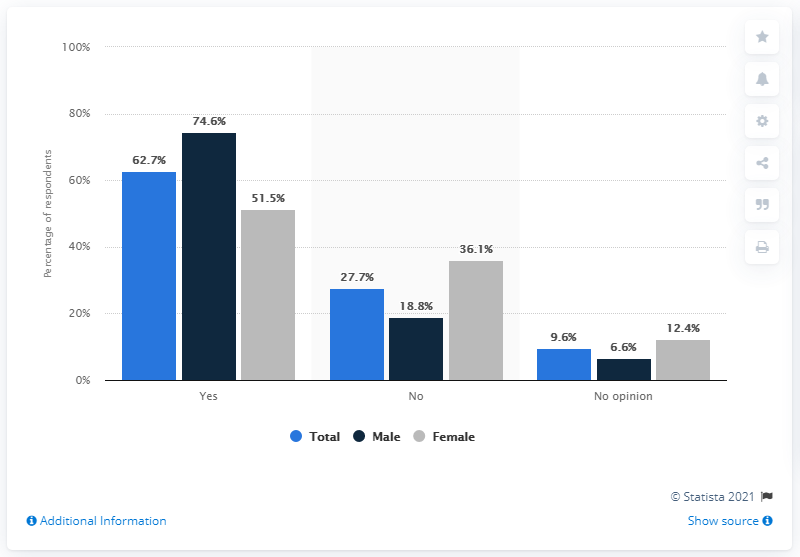Draw attention to some important aspects in this diagram. According to our survey, 74.6% of male respondents consider themselves to be football fans. According to the survey, 51.5% of female respondents consider themselves to be football fans. 